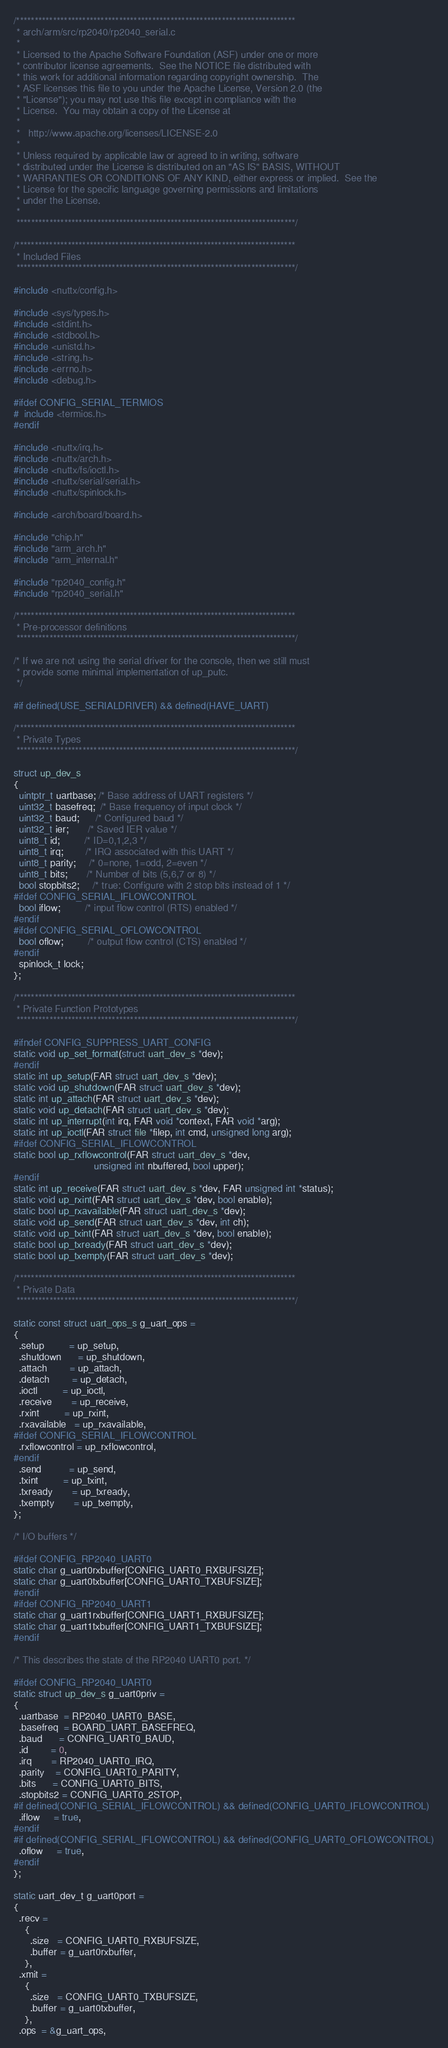<code> <loc_0><loc_0><loc_500><loc_500><_C_>/****************************************************************************
 * arch/arm/src/rp2040/rp2040_serial.c
 *
 * Licensed to the Apache Software Foundation (ASF) under one or more
 * contributor license agreements.  See the NOTICE file distributed with
 * this work for additional information regarding copyright ownership.  The
 * ASF licenses this file to you under the Apache License, Version 2.0 (the
 * "License"); you may not use this file except in compliance with the
 * License.  You may obtain a copy of the License at
 *
 *   http://www.apache.org/licenses/LICENSE-2.0
 *
 * Unless required by applicable law or agreed to in writing, software
 * distributed under the License is distributed on an "AS IS" BASIS, WITHOUT
 * WARRANTIES OR CONDITIONS OF ANY KIND, either express or implied.  See the
 * License for the specific language governing permissions and limitations
 * under the License.
 *
 ****************************************************************************/

/****************************************************************************
 * Included Files
 ****************************************************************************/

#include <nuttx/config.h>

#include <sys/types.h>
#include <stdint.h>
#include <stdbool.h>
#include <unistd.h>
#include <string.h>
#include <errno.h>
#include <debug.h>

#ifdef CONFIG_SERIAL_TERMIOS
#  include <termios.h>
#endif

#include <nuttx/irq.h>
#include <nuttx/arch.h>
#include <nuttx/fs/ioctl.h>
#include <nuttx/serial/serial.h>
#include <nuttx/spinlock.h>

#include <arch/board/board.h>

#include "chip.h"
#include "arm_arch.h"
#include "arm_internal.h"

#include "rp2040_config.h"
#include "rp2040_serial.h"

/****************************************************************************
 * Pre-processor definitions
 ****************************************************************************/

/* If we are not using the serial driver for the console, then we still must
 * provide some minimal implementation of up_putc.
 */

#if defined(USE_SERIALDRIVER) && defined(HAVE_UART)

/****************************************************************************
 * Private Types
 ****************************************************************************/

struct up_dev_s
{
  uintptr_t uartbase; /* Base address of UART registers */
  uint32_t basefreq;  /* Base frequency of input clock */
  uint32_t baud;      /* Configured baud */
  uint32_t ier;       /* Saved IER value */
  uint8_t id;         /* ID=0,1,2,3 */
  uint8_t irq;        /* IRQ associated with this UART */
  uint8_t parity;     /* 0=none, 1=odd, 2=even */
  uint8_t bits;       /* Number of bits (5,6,7 or 8) */
  bool stopbits2;     /* true: Configure with 2 stop bits instead of 1 */
#ifdef CONFIG_SERIAL_IFLOWCONTROL
  bool iflow;         /* input flow control (RTS) enabled */
#endif
#ifdef CONFIG_SERIAL_OFLOWCONTROL
  bool oflow;         /* output flow control (CTS) enabled */
#endif
  spinlock_t lock;
};

/****************************************************************************
 * Private Function Prototypes
 ****************************************************************************/

#ifndef CONFIG_SUPPRESS_UART_CONFIG
static void up_set_format(struct uart_dev_s *dev);
#endif
static int up_setup(FAR struct uart_dev_s *dev);
static void up_shutdown(FAR struct uart_dev_s *dev);
static int up_attach(FAR struct uart_dev_s *dev);
static void up_detach(FAR struct uart_dev_s *dev);
static int up_interrupt(int irq, FAR void *context, FAR void *arg);
static int up_ioctl(FAR struct file *filep, int cmd, unsigned long arg);
#ifdef CONFIG_SERIAL_IFLOWCONTROL
static bool up_rxflowcontrol(FAR struct uart_dev_s *dev,
                             unsigned int nbuffered, bool upper);
#endif
static int up_receive(FAR struct uart_dev_s *dev, FAR unsigned int *status);
static void up_rxint(FAR struct uart_dev_s *dev, bool enable);
static bool up_rxavailable(FAR struct uart_dev_s *dev);
static void up_send(FAR struct uart_dev_s *dev, int ch);
static void up_txint(FAR struct uart_dev_s *dev, bool enable);
static bool up_txready(FAR struct uart_dev_s *dev);
static bool up_txempty(FAR struct uart_dev_s *dev);

/****************************************************************************
 * Private Data
 ****************************************************************************/

static const struct uart_ops_s g_uart_ops =
{
  .setup         = up_setup,
  .shutdown      = up_shutdown,
  .attach        = up_attach,
  .detach        = up_detach,
  .ioctl         = up_ioctl,
  .receive       = up_receive,
  .rxint         = up_rxint,
  .rxavailable   = up_rxavailable,
#ifdef CONFIG_SERIAL_IFLOWCONTROL
  .rxflowcontrol = up_rxflowcontrol,
#endif
  .send          = up_send,
  .txint         = up_txint,
  .txready       = up_txready,
  .txempty       = up_txempty,
};

/* I/O buffers */

#ifdef CONFIG_RP2040_UART0
static char g_uart0rxbuffer[CONFIG_UART0_RXBUFSIZE];
static char g_uart0txbuffer[CONFIG_UART0_TXBUFSIZE];
#endif
#ifdef CONFIG_RP2040_UART1
static char g_uart1rxbuffer[CONFIG_UART1_RXBUFSIZE];
static char g_uart1txbuffer[CONFIG_UART1_TXBUFSIZE];
#endif

/* This describes the state of the RP2040 UART0 port. */

#ifdef CONFIG_RP2040_UART0
static struct up_dev_s g_uart0priv =
{
  .uartbase  = RP2040_UART0_BASE,
  .basefreq  = BOARD_UART_BASEFREQ,
  .baud      = CONFIG_UART0_BAUD,
  .id        = 0,
  .irq       = RP2040_UART0_IRQ,
  .parity    = CONFIG_UART0_PARITY,
  .bits      = CONFIG_UART0_BITS,
  .stopbits2 = CONFIG_UART0_2STOP,
#if defined(CONFIG_SERIAL_IFLOWCONTROL) && defined(CONFIG_UART0_IFLOWCONTROL)
  .iflow     = true,
#endif
#if defined(CONFIG_SERIAL_IFLOWCONTROL) && defined(CONFIG_UART0_OFLOWCONTROL)
  .oflow     = true,
#endif
};

static uart_dev_t g_uart0port =
{
  .recv =
    {
      .size   = CONFIG_UART0_RXBUFSIZE,
      .buffer = g_uart0rxbuffer,
    },
  .xmit =
    {
      .size   = CONFIG_UART0_TXBUFSIZE,
      .buffer = g_uart0txbuffer,
    },
  .ops  = &g_uart_ops,</code> 